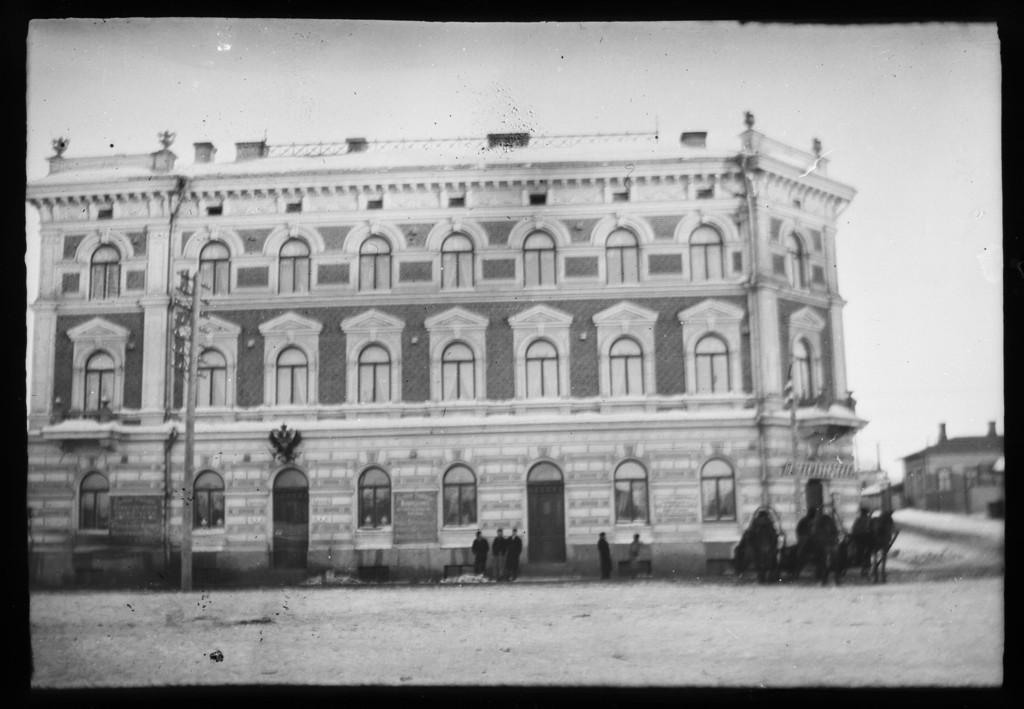Please provide a concise description of this image. In this image we can see there is a poster with buildings and there are people standing on the ground. And there is a current pole and the sky. 